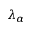Convert formula to latex. <formula><loc_0><loc_0><loc_500><loc_500>\lambda _ { \alpha }</formula> 